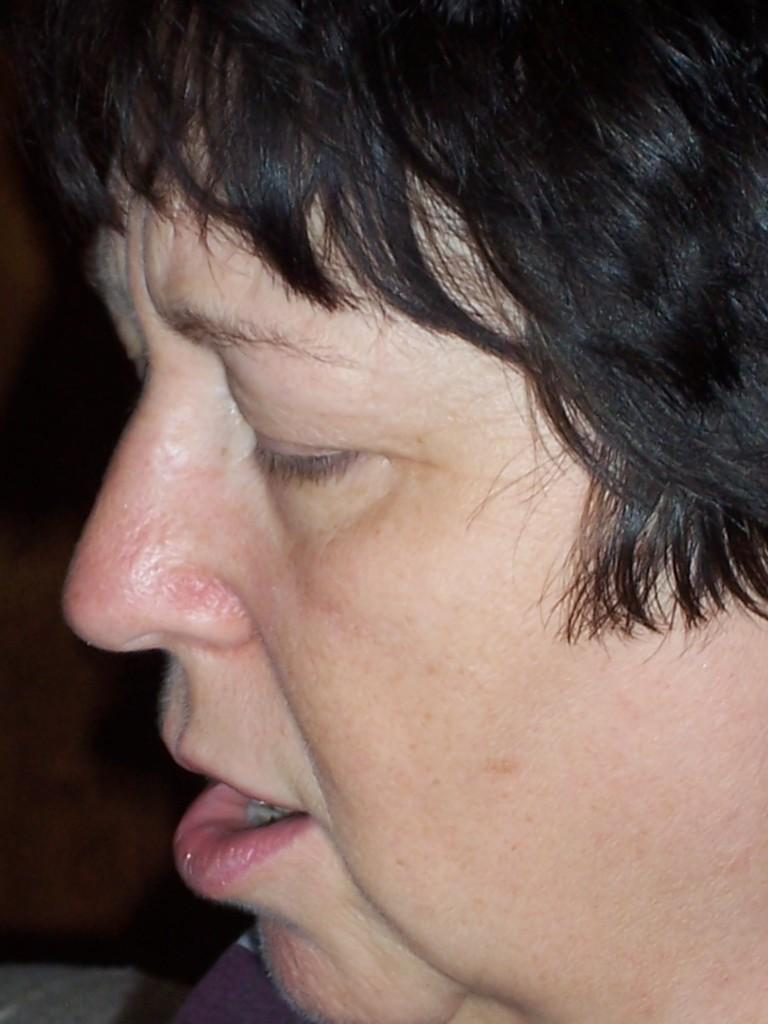What is the main subject of the image? The main subject of the image is the face of a person. What can be seen behind the person's face in the image? The backdrop of the image is dark. How many degrees can be seen on the door in the image? There is no door present in the image, and therefore no degrees can be seen. 